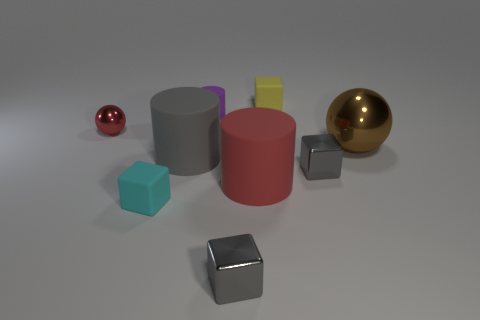Subtract all tiny yellow blocks. How many blocks are left? 3 Subtract all cyan cubes. How many cubes are left? 3 Subtract all green balls. How many gray cylinders are left? 1 Subtract all rubber objects. Subtract all green spheres. How many objects are left? 4 Add 2 red cylinders. How many red cylinders are left? 3 Add 5 small cyan rubber things. How many small cyan rubber things exist? 6 Subtract 0 green spheres. How many objects are left? 9 Subtract all cylinders. How many objects are left? 6 Subtract 2 cylinders. How many cylinders are left? 1 Subtract all yellow cylinders. Subtract all green spheres. How many cylinders are left? 3 